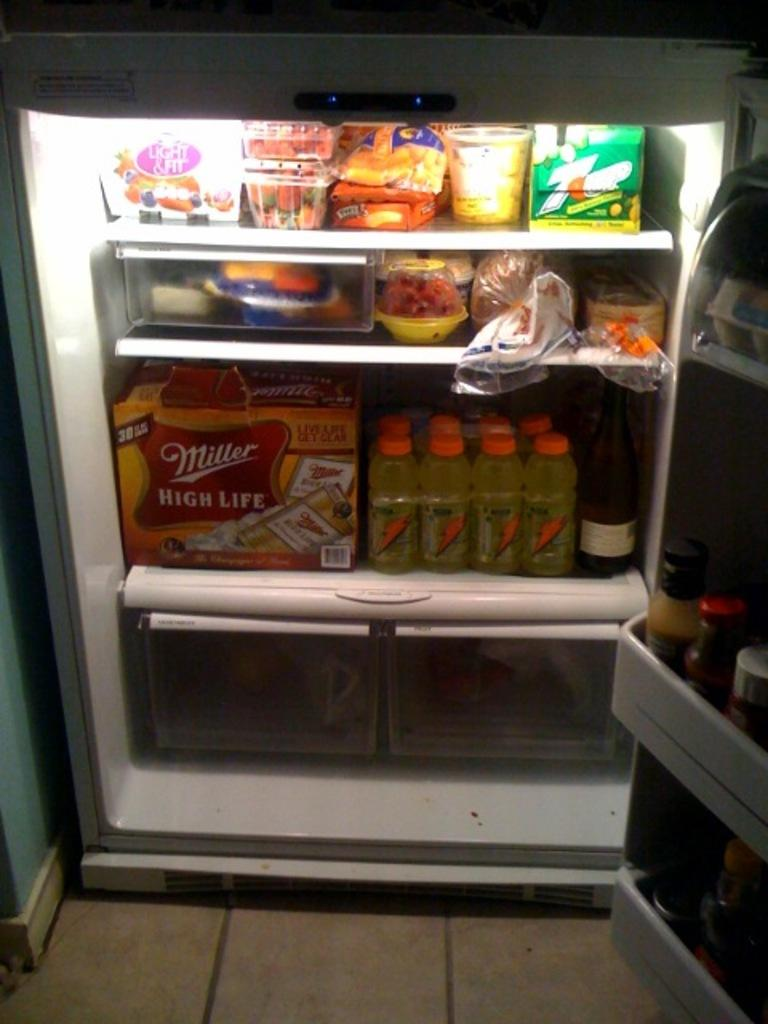<image>
Relay a brief, clear account of the picture shown. an open refrigerator with a box of miller high life in the bottom shelf 